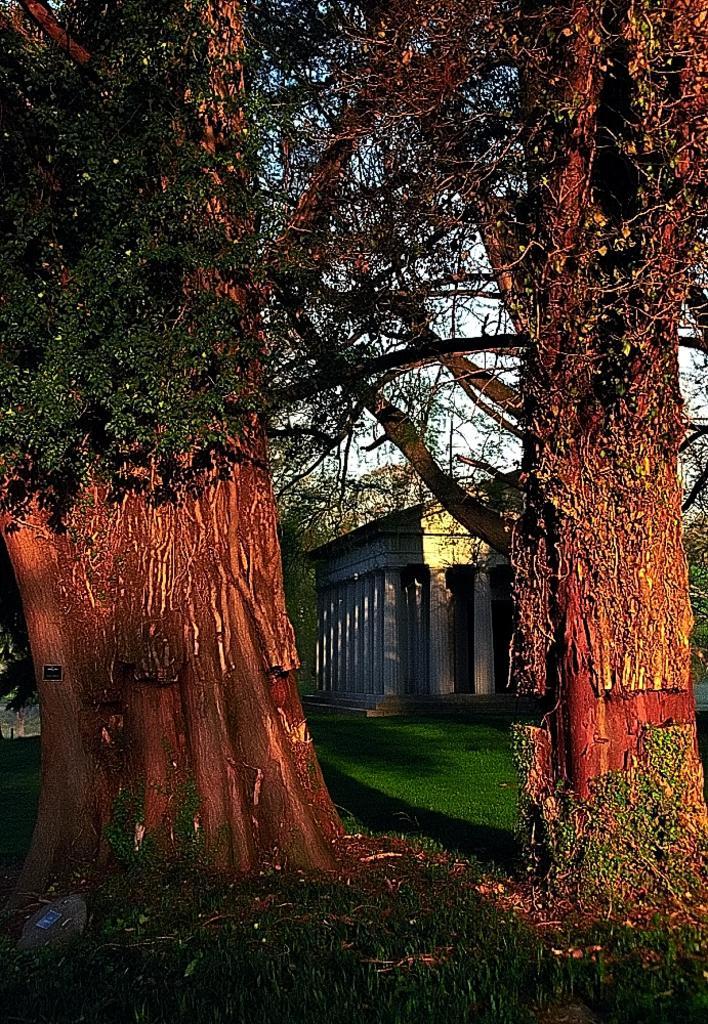Describe this image in one or two sentences. In this image, we can see trees and there is a house. At the bottom, there is ground. 